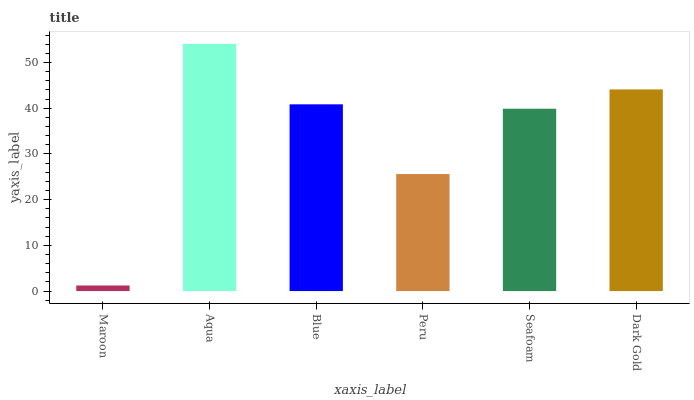Is Blue the minimum?
Answer yes or no. No. Is Blue the maximum?
Answer yes or no. No. Is Aqua greater than Blue?
Answer yes or no. Yes. Is Blue less than Aqua?
Answer yes or no. Yes. Is Blue greater than Aqua?
Answer yes or no. No. Is Aqua less than Blue?
Answer yes or no. No. Is Blue the high median?
Answer yes or no. Yes. Is Seafoam the low median?
Answer yes or no. Yes. Is Maroon the high median?
Answer yes or no. No. Is Dark Gold the low median?
Answer yes or no. No. 